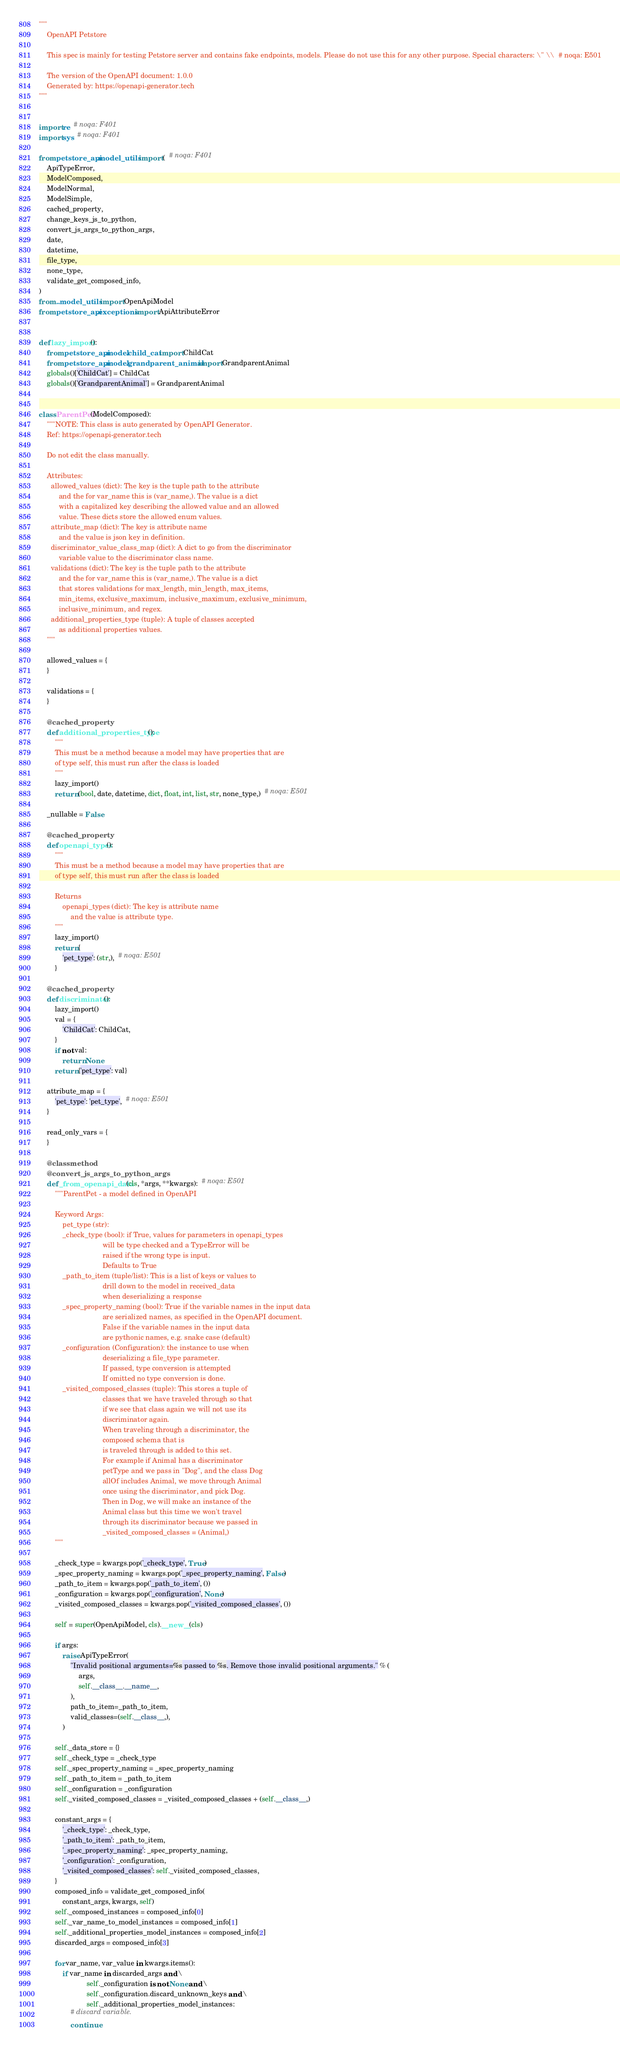Convert code to text. <code><loc_0><loc_0><loc_500><loc_500><_Python_>"""
    OpenAPI Petstore

    This spec is mainly for testing Petstore server and contains fake endpoints, models. Please do not use this for any other purpose. Special characters: \" \\  # noqa: E501

    The version of the OpenAPI document: 1.0.0
    Generated by: https://openapi-generator.tech
"""


import re  # noqa: F401
import sys  # noqa: F401

from petstore_api.model_utils import (  # noqa: F401
    ApiTypeError,
    ModelComposed,
    ModelNormal,
    ModelSimple,
    cached_property,
    change_keys_js_to_python,
    convert_js_args_to_python_args,
    date,
    datetime,
    file_type,
    none_type,
    validate_get_composed_info,
)
from ..model_utils import OpenApiModel
from petstore_api.exceptions import ApiAttributeError


def lazy_import():
    from petstore_api.model.child_cat import ChildCat
    from petstore_api.model.grandparent_animal import GrandparentAnimal
    globals()['ChildCat'] = ChildCat
    globals()['GrandparentAnimal'] = GrandparentAnimal


class ParentPet(ModelComposed):
    """NOTE: This class is auto generated by OpenAPI Generator.
    Ref: https://openapi-generator.tech

    Do not edit the class manually.

    Attributes:
      allowed_values (dict): The key is the tuple path to the attribute
          and the for var_name this is (var_name,). The value is a dict
          with a capitalized key describing the allowed value and an allowed
          value. These dicts store the allowed enum values.
      attribute_map (dict): The key is attribute name
          and the value is json key in definition.
      discriminator_value_class_map (dict): A dict to go from the discriminator
          variable value to the discriminator class name.
      validations (dict): The key is the tuple path to the attribute
          and the for var_name this is (var_name,). The value is a dict
          that stores validations for max_length, min_length, max_items,
          min_items, exclusive_maximum, inclusive_maximum, exclusive_minimum,
          inclusive_minimum, and regex.
      additional_properties_type (tuple): A tuple of classes accepted
          as additional properties values.
    """

    allowed_values = {
    }

    validations = {
    }

    @cached_property
    def additional_properties_type():
        """
        This must be a method because a model may have properties that are
        of type self, this must run after the class is loaded
        """
        lazy_import()
        return (bool, date, datetime, dict, float, int, list, str, none_type,)  # noqa: E501

    _nullable = False

    @cached_property
    def openapi_types():
        """
        This must be a method because a model may have properties that are
        of type self, this must run after the class is loaded

        Returns
            openapi_types (dict): The key is attribute name
                and the value is attribute type.
        """
        lazy_import()
        return {
            'pet_type': (str,),  # noqa: E501
        }

    @cached_property
    def discriminator():
        lazy_import()
        val = {
            'ChildCat': ChildCat,
        }
        if not val:
            return None
        return {'pet_type': val}

    attribute_map = {
        'pet_type': 'pet_type',  # noqa: E501
    }

    read_only_vars = {
    }

    @classmethod
    @convert_js_args_to_python_args
    def _from_openapi_data(cls, *args, **kwargs):  # noqa: E501
        """ParentPet - a model defined in OpenAPI

        Keyword Args:
            pet_type (str):
            _check_type (bool): if True, values for parameters in openapi_types
                                will be type checked and a TypeError will be
                                raised if the wrong type is input.
                                Defaults to True
            _path_to_item (tuple/list): This is a list of keys or values to
                                drill down to the model in received_data
                                when deserializing a response
            _spec_property_naming (bool): True if the variable names in the input data
                                are serialized names, as specified in the OpenAPI document.
                                False if the variable names in the input data
                                are pythonic names, e.g. snake case (default)
            _configuration (Configuration): the instance to use when
                                deserializing a file_type parameter.
                                If passed, type conversion is attempted
                                If omitted no type conversion is done.
            _visited_composed_classes (tuple): This stores a tuple of
                                classes that we have traveled through so that
                                if we see that class again we will not use its
                                discriminator again.
                                When traveling through a discriminator, the
                                composed schema that is
                                is traveled through is added to this set.
                                For example if Animal has a discriminator
                                petType and we pass in "Dog", and the class Dog
                                allOf includes Animal, we move through Animal
                                once using the discriminator, and pick Dog.
                                Then in Dog, we will make an instance of the
                                Animal class but this time we won't travel
                                through its discriminator because we passed in
                                _visited_composed_classes = (Animal,)
        """

        _check_type = kwargs.pop('_check_type', True)
        _spec_property_naming = kwargs.pop('_spec_property_naming', False)
        _path_to_item = kwargs.pop('_path_to_item', ())
        _configuration = kwargs.pop('_configuration', None)
        _visited_composed_classes = kwargs.pop('_visited_composed_classes', ())

        self = super(OpenApiModel, cls).__new__(cls)

        if args:
            raise ApiTypeError(
                "Invalid positional arguments=%s passed to %s. Remove those invalid positional arguments." % (
                    args,
                    self.__class__.__name__,
                ),
                path_to_item=_path_to_item,
                valid_classes=(self.__class__,),
            )

        self._data_store = {}
        self._check_type = _check_type
        self._spec_property_naming = _spec_property_naming
        self._path_to_item = _path_to_item
        self._configuration = _configuration
        self._visited_composed_classes = _visited_composed_classes + (self.__class__,)

        constant_args = {
            '_check_type': _check_type,
            '_path_to_item': _path_to_item,
            '_spec_property_naming': _spec_property_naming,
            '_configuration': _configuration,
            '_visited_composed_classes': self._visited_composed_classes,
        }
        composed_info = validate_get_composed_info(
            constant_args, kwargs, self)
        self._composed_instances = composed_info[0]
        self._var_name_to_model_instances = composed_info[1]
        self._additional_properties_model_instances = composed_info[2]
        discarded_args = composed_info[3]

        for var_name, var_value in kwargs.items():
            if var_name in discarded_args and \
                        self._configuration is not None and \
                        self._configuration.discard_unknown_keys and \
                        self._additional_properties_model_instances:
                # discard variable.
                continue</code> 